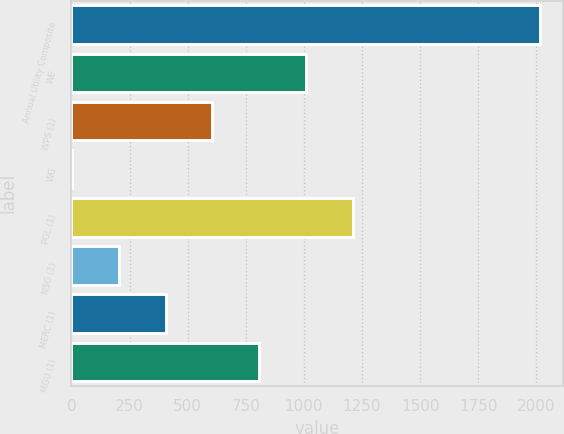<chart> <loc_0><loc_0><loc_500><loc_500><bar_chart><fcel>Annual Utility Composite<fcel>WE<fcel>WPS (1)<fcel>WG<fcel>PGL (1)<fcel>NSG (1)<fcel>MERC (1)<fcel>MGU (1)<nl><fcel>2016<fcel>1009.19<fcel>606.45<fcel>2.34<fcel>1210.56<fcel>203.71<fcel>405.08<fcel>807.82<nl></chart> 